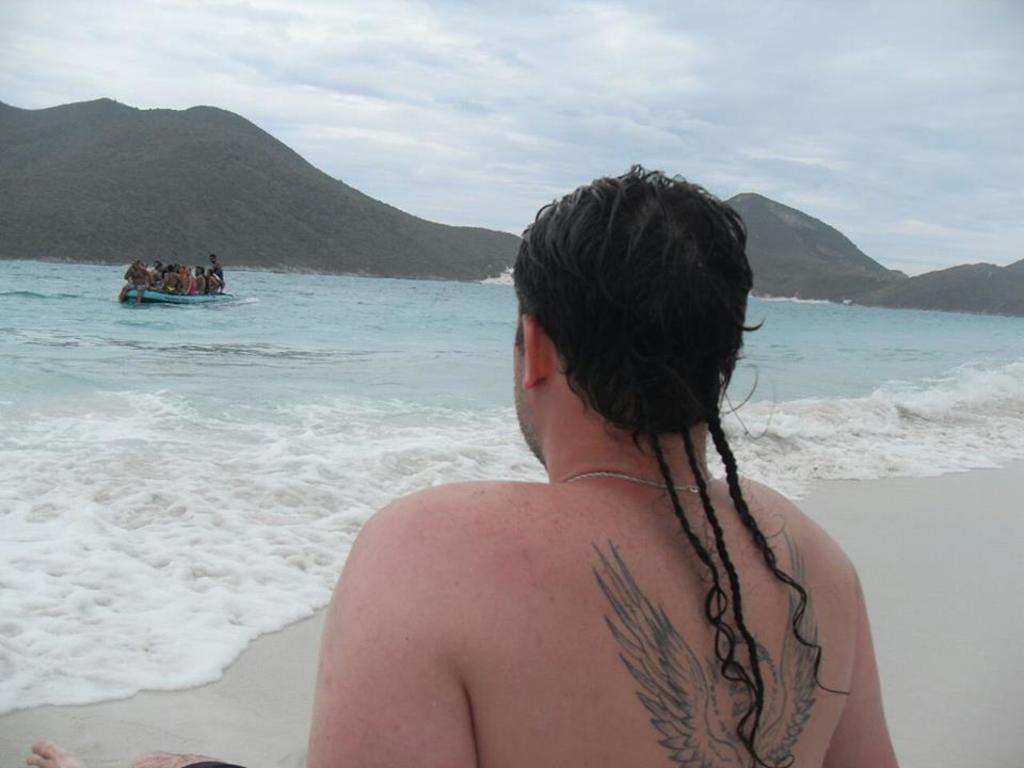Could you give a brief overview of what you see in this image? In this picture I can observe a person in the beach. In front of him there is an ocean. I can observe a boat floating on the water. In the background there are hills and some clouds in the sky. 